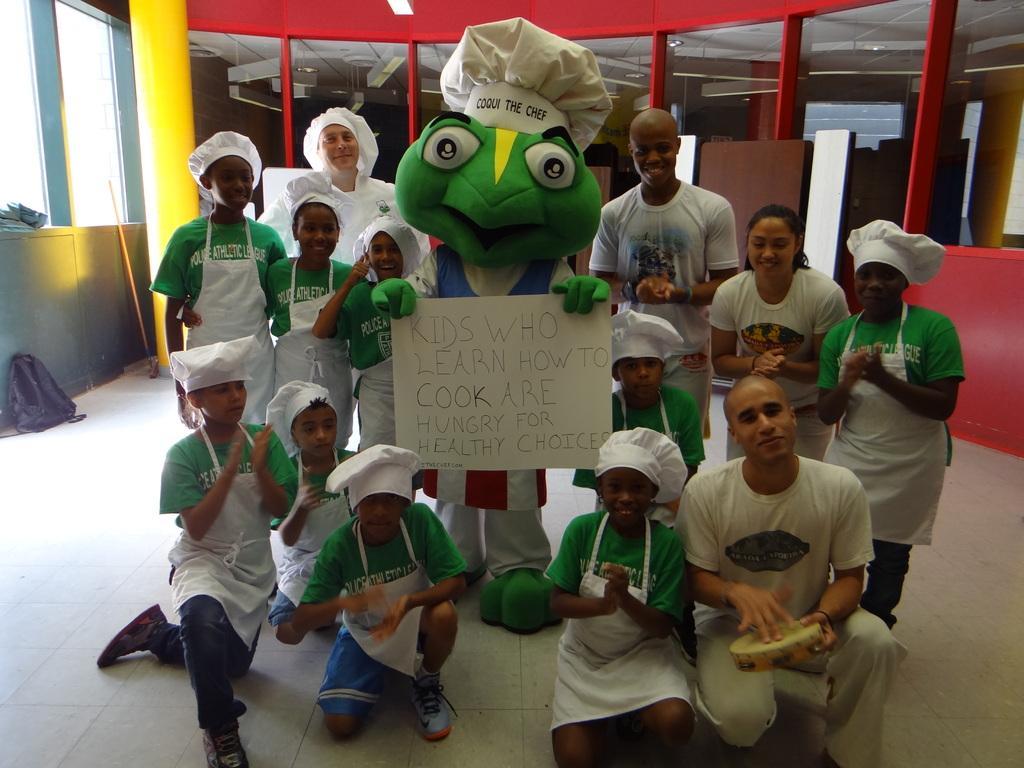Please provide a concise description of this image. In this picture, we see a man is wearing the mascot costume. He is holding a white chart with some text written on it. Beside him, we see people are standing and most of them are wearing the white aprons and white bonnets. Behind them, we see the glass doors and a wall in red color. On the left side, we see a yellow pillar, stick, window, black bag and a grey wall. 